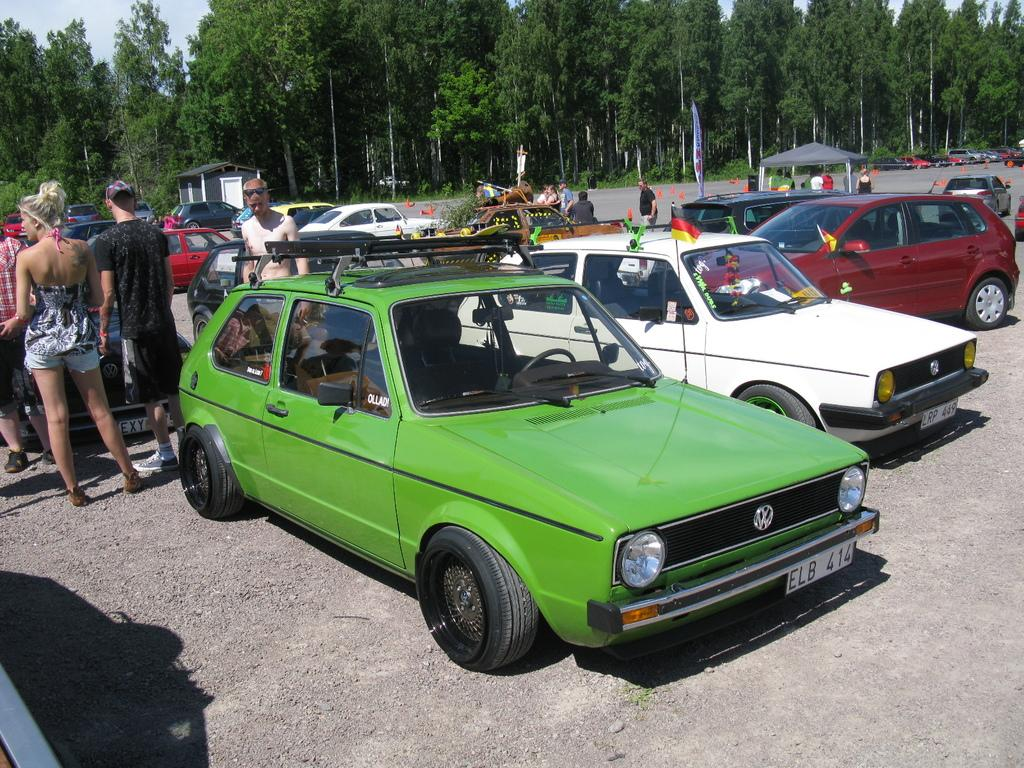What can be seen on the ground in the image? There are vehicles on the ground in the image. Who or what else is present in the image? There are people and flags in the image. What type of natural elements can be seen in the image? There are trees in the image. Are there any structures visible in the image? Yes, there are sheds in the image. What is visible in the background of the image? The sky is visible in the image. Can you see any polish being applied to the vehicles in the image? There is no indication of polish or any maintenance activity being performed on the vehicles in the image. What type of waves can be seen in the image? There are no waves present in the image; it features vehicles, people, flags, trees, sheds, and the sky. 